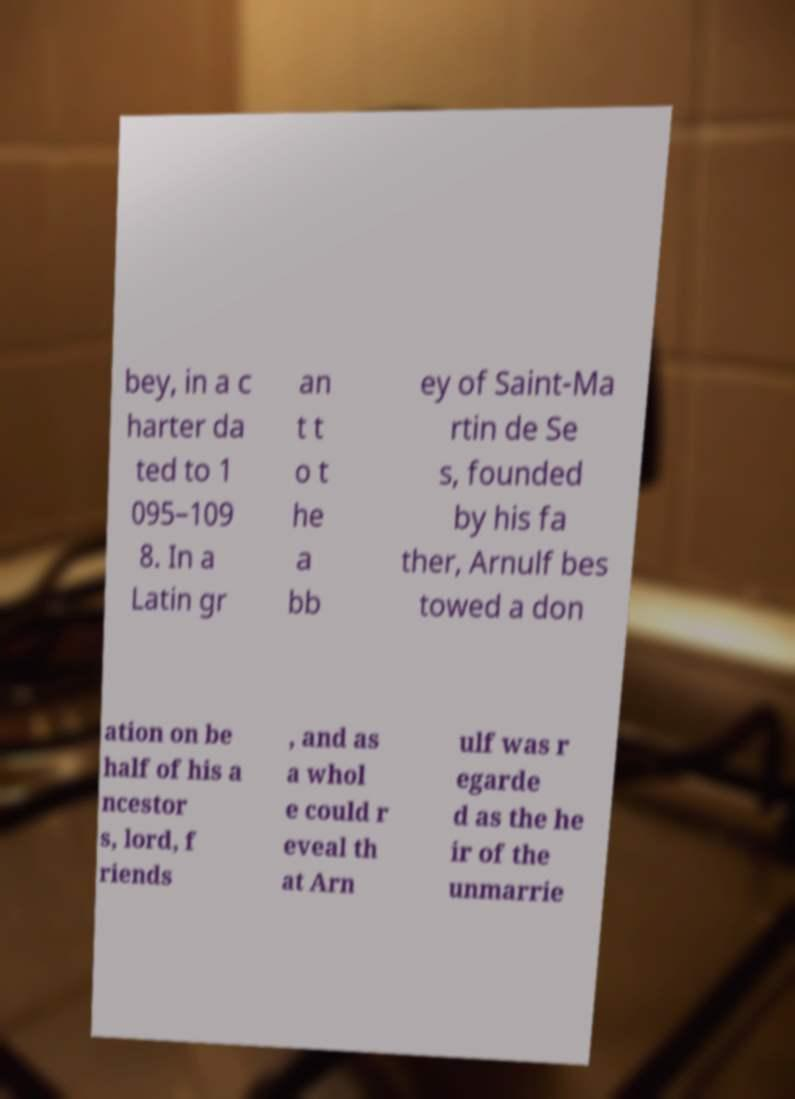Can you read and provide the text displayed in the image?This photo seems to have some interesting text. Can you extract and type it out for me? bey, in a c harter da ted to 1 095–109 8. In a Latin gr an t t o t he a bb ey of Saint-Ma rtin de Se s, founded by his fa ther, Arnulf bes towed a don ation on be half of his a ncestor s, lord, f riends , and as a whol e could r eveal th at Arn ulf was r egarde d as the he ir of the unmarrie 